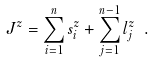Convert formula to latex. <formula><loc_0><loc_0><loc_500><loc_500>J ^ { z } = \sum ^ { n } _ { i = 1 } s ^ { z } _ { i } + \sum ^ { n - 1 } _ { j = 1 } l ^ { z } _ { j } \ .</formula> 